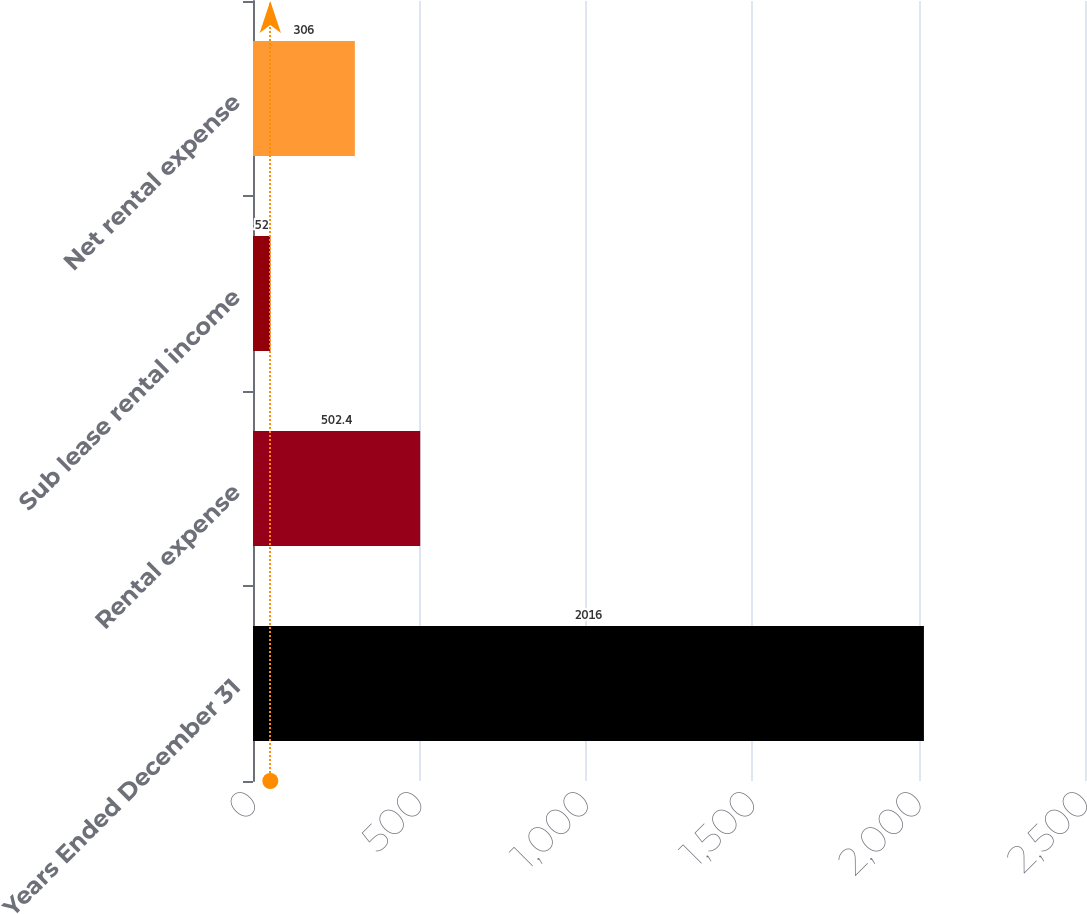<chart> <loc_0><loc_0><loc_500><loc_500><bar_chart><fcel>Years Ended December 31<fcel>Rental expense<fcel>Sub lease rental income<fcel>Net rental expense<nl><fcel>2016<fcel>502.4<fcel>52<fcel>306<nl></chart> 